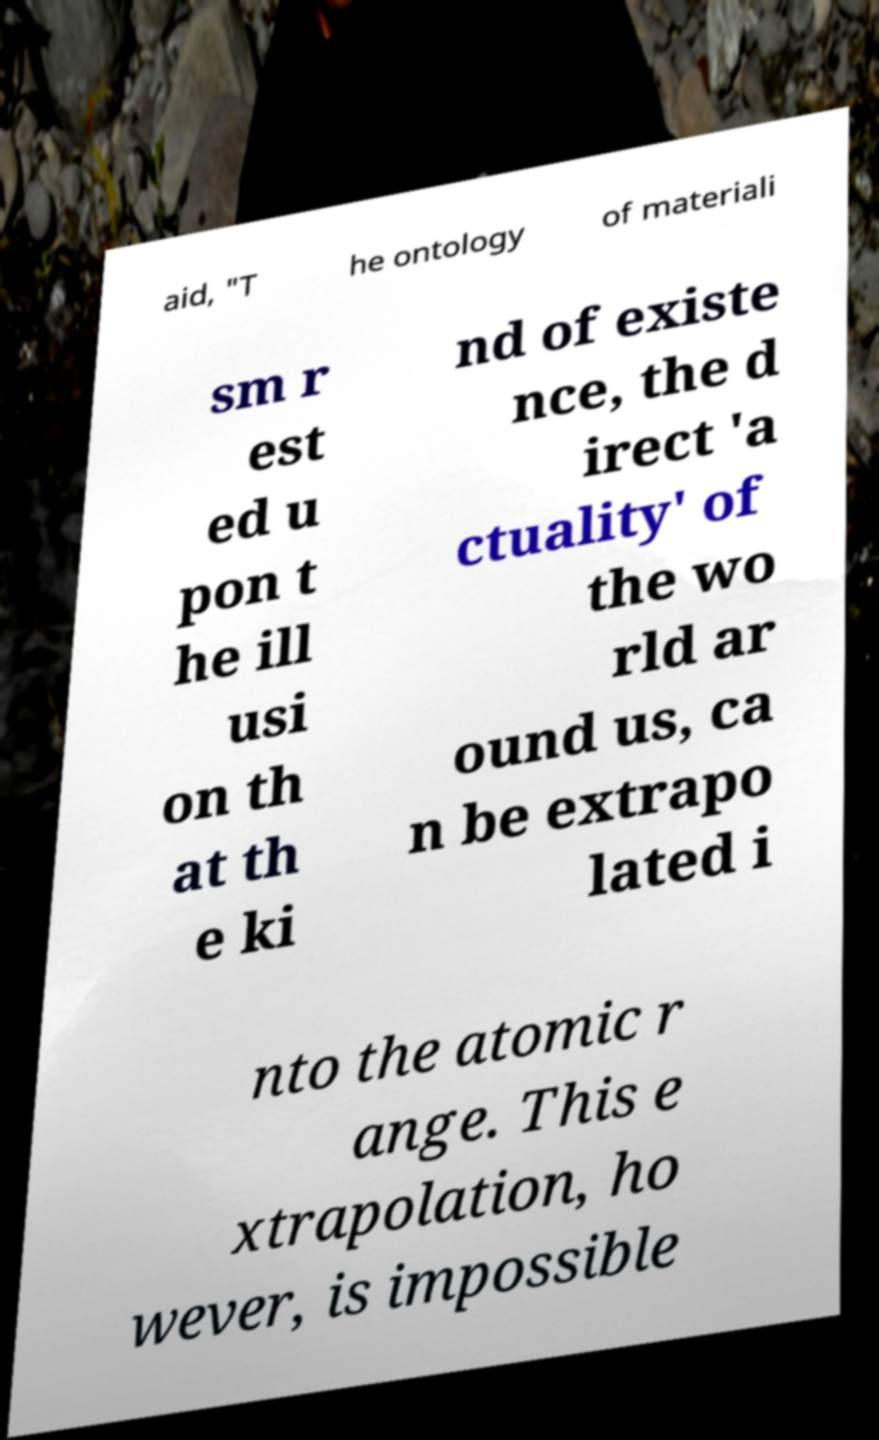What messages or text are displayed in this image? I need them in a readable, typed format. aid, "T he ontology of materiali sm r est ed u pon t he ill usi on th at th e ki nd of existe nce, the d irect 'a ctuality' of the wo rld ar ound us, ca n be extrapo lated i nto the atomic r ange. This e xtrapolation, ho wever, is impossible 